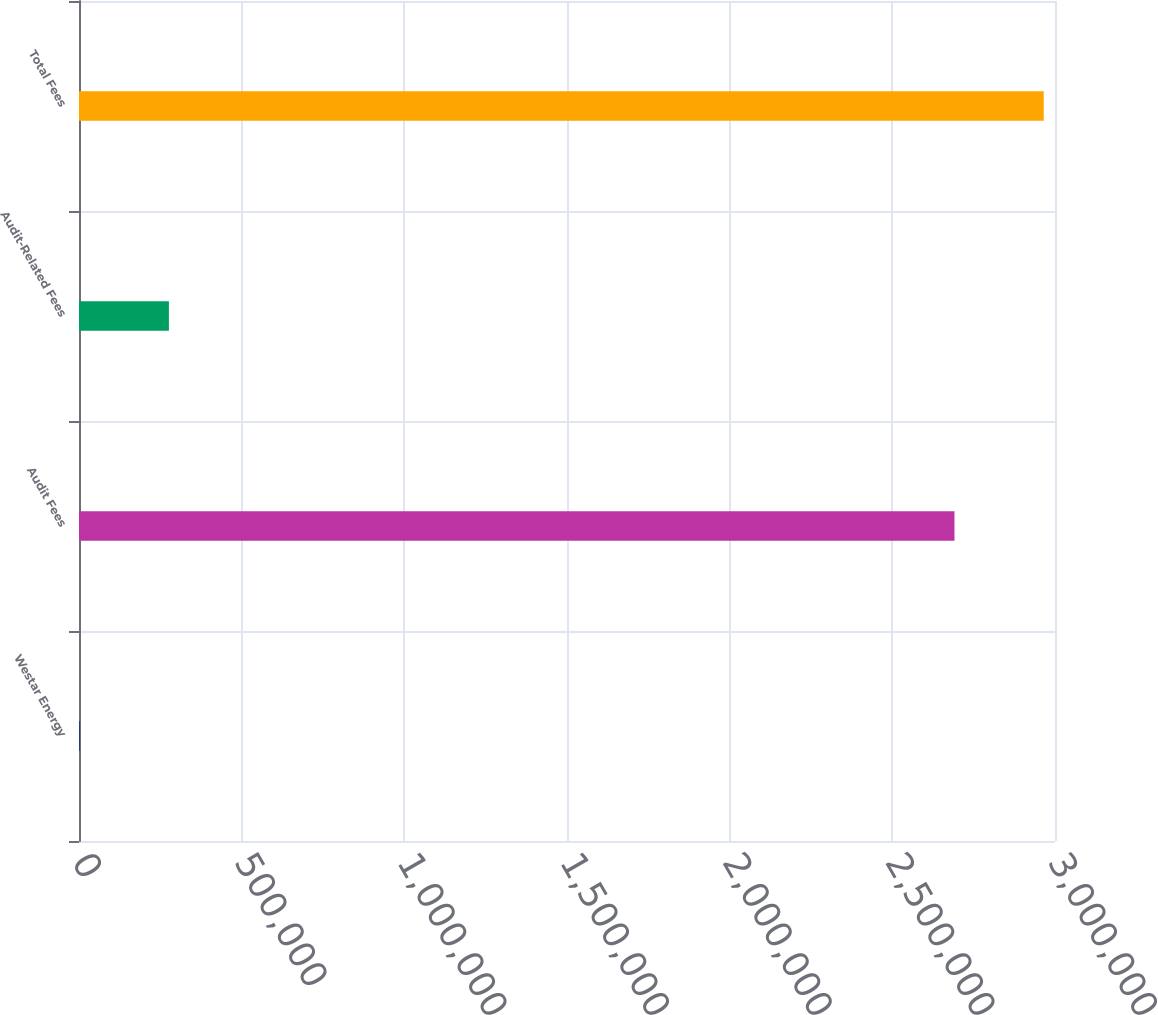<chart> <loc_0><loc_0><loc_500><loc_500><bar_chart><fcel>Westar Energy<fcel>Audit Fees<fcel>Audit-Related Fees<fcel>Total Fees<nl><fcel>2017<fcel>2.691e+06<fcel>276315<fcel>2.9653e+06<nl></chart> 